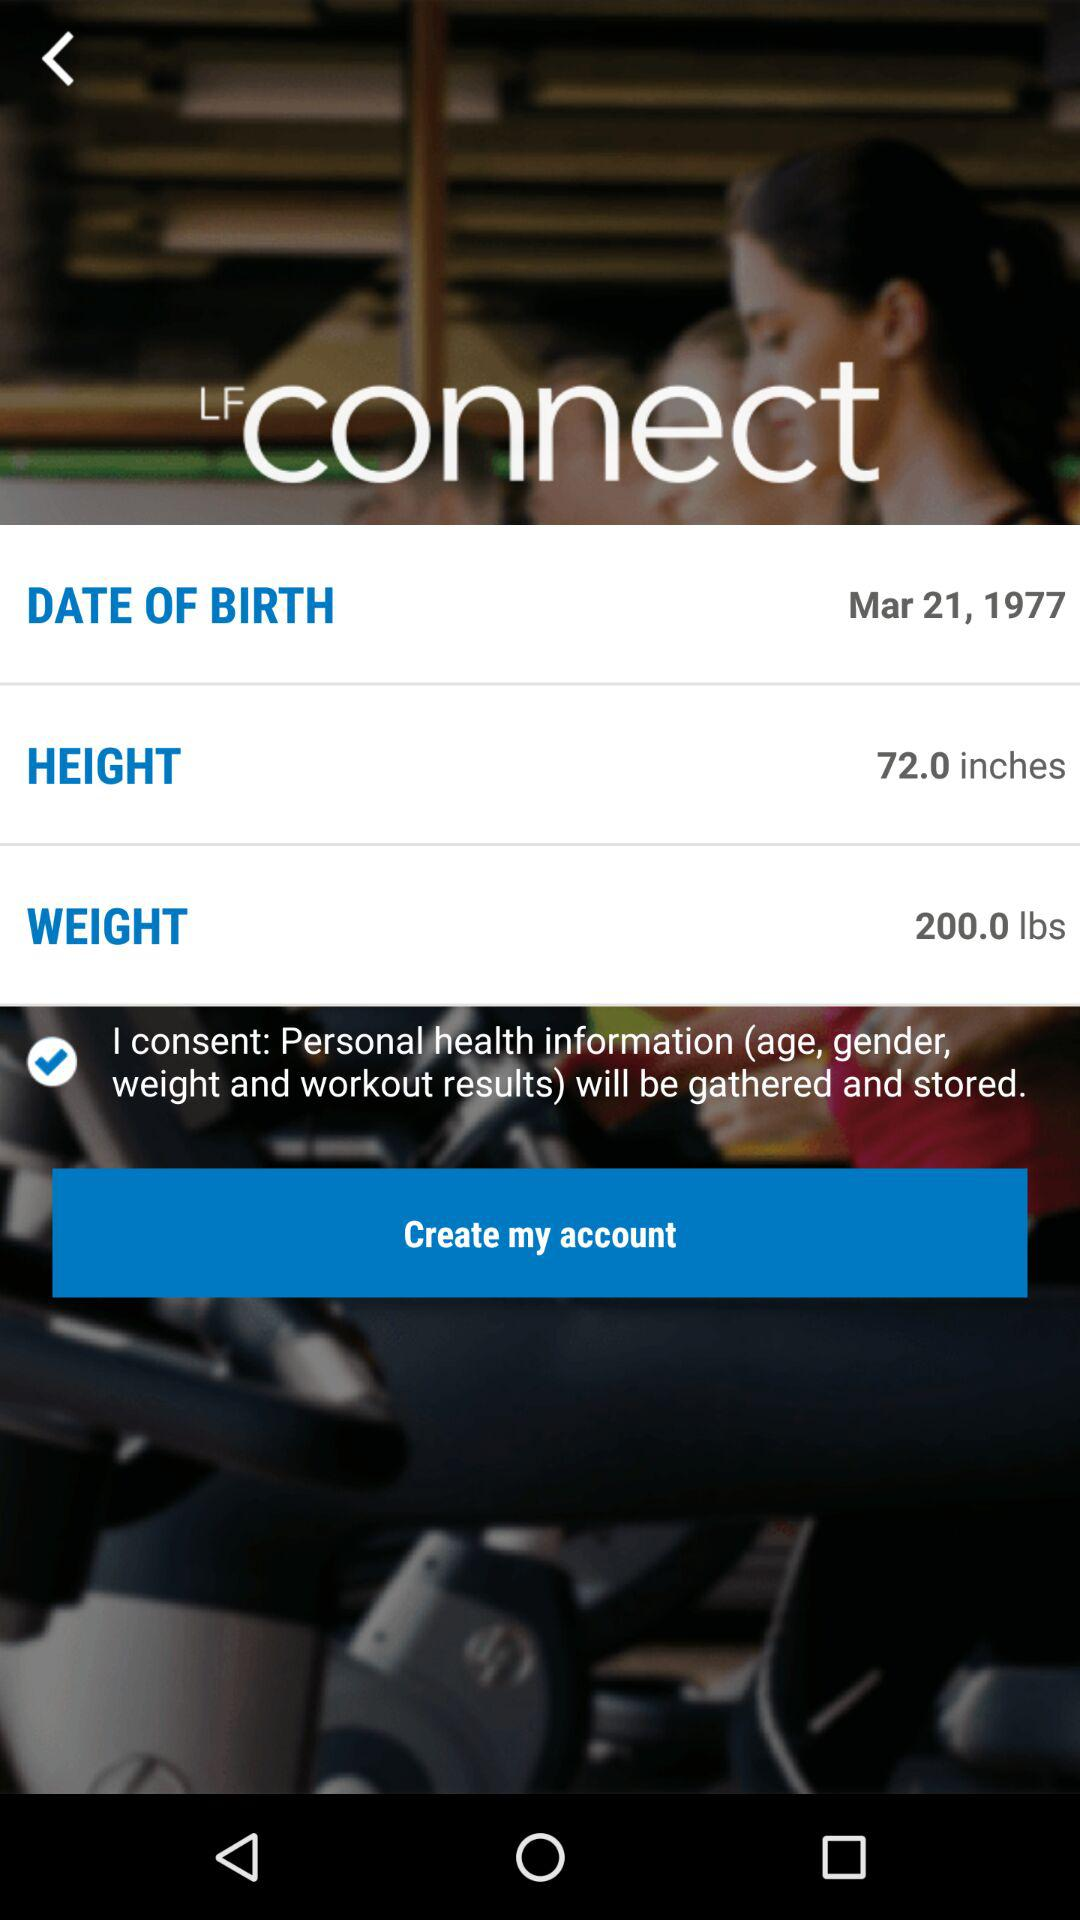What is the date of birth shown on the screen? The shown date of birth is March 21, 1977. 